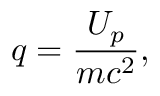<formula> <loc_0><loc_0><loc_500><loc_500>q = \frac { U _ { p } } { m c ^ { 2 } } ,</formula> 